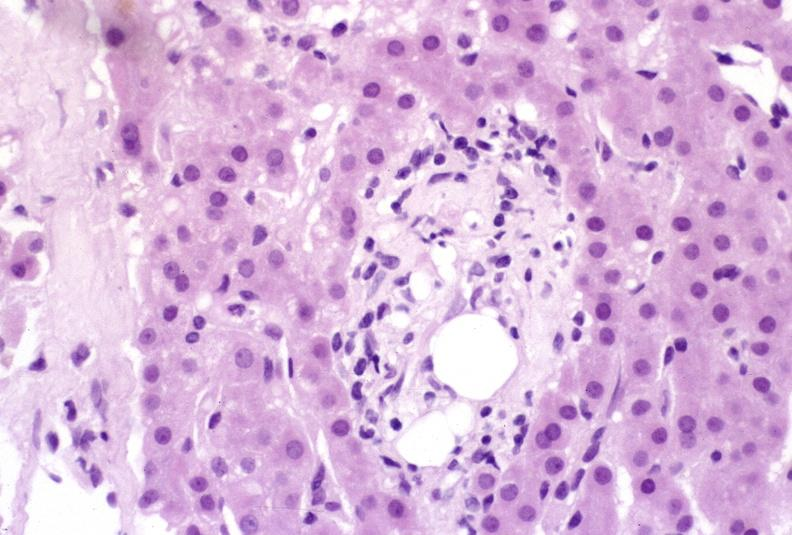s this frontal section micronodular photo present?
Answer the question using a single word or phrase. No 